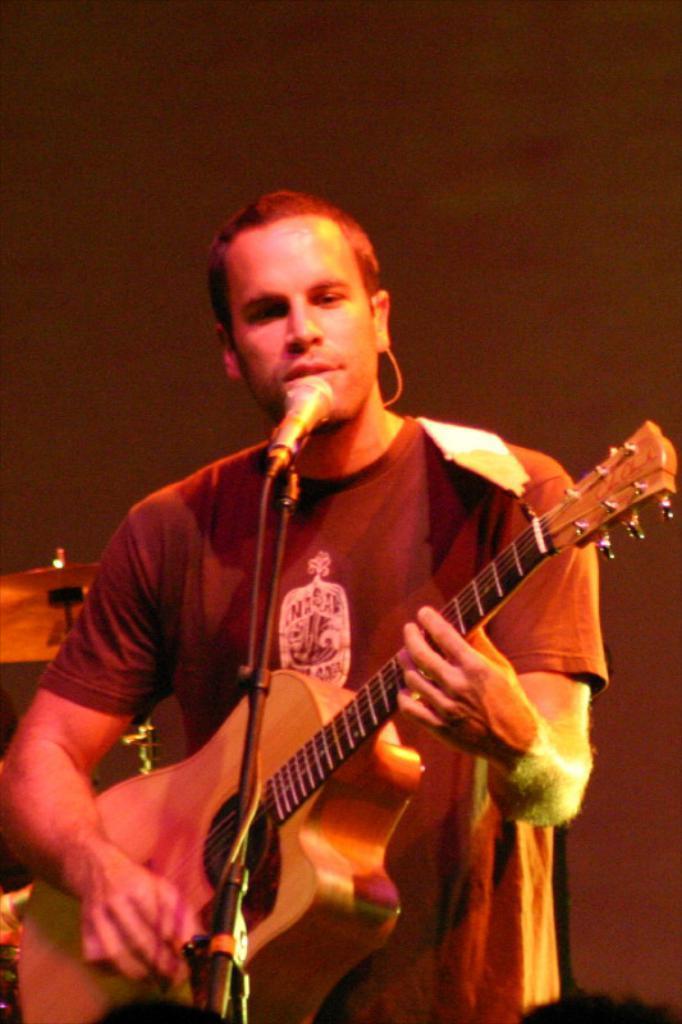Can you describe this image briefly? In this image there is a person standing and playing guitar. At the front there is a microphone and at the back there are drums. 